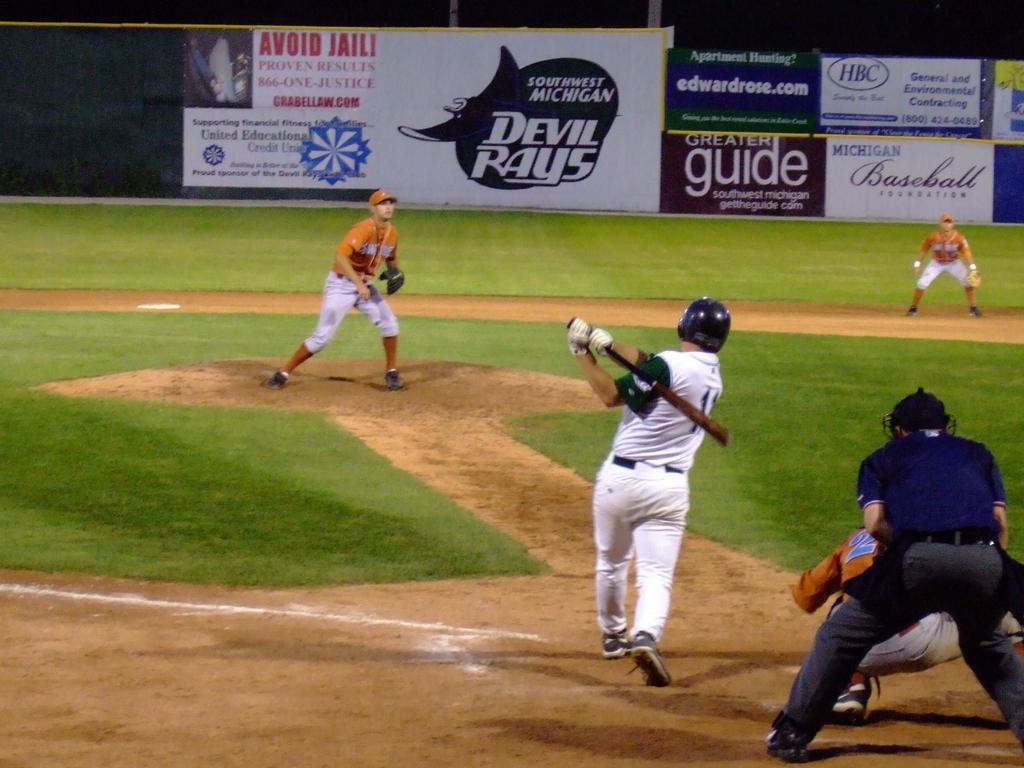Please provide a concise description of this image. In this image I can see a person wearing white colored dress is standing and holding a bat in his hand. I can see few other persons wearing orange and white colored dresses and a person wearing blue and black colored dress is standing behind him. In the background I can see few banners. 